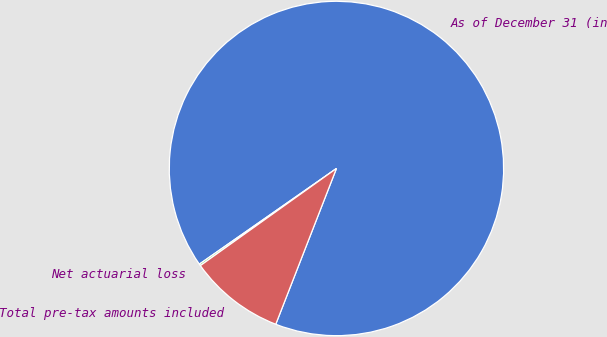Convert chart to OTSL. <chart><loc_0><loc_0><loc_500><loc_500><pie_chart><fcel>As of December 31 (in<fcel>Net actuarial loss<fcel>Total pre-tax amounts included<nl><fcel>90.61%<fcel>0.17%<fcel>9.22%<nl></chart> 